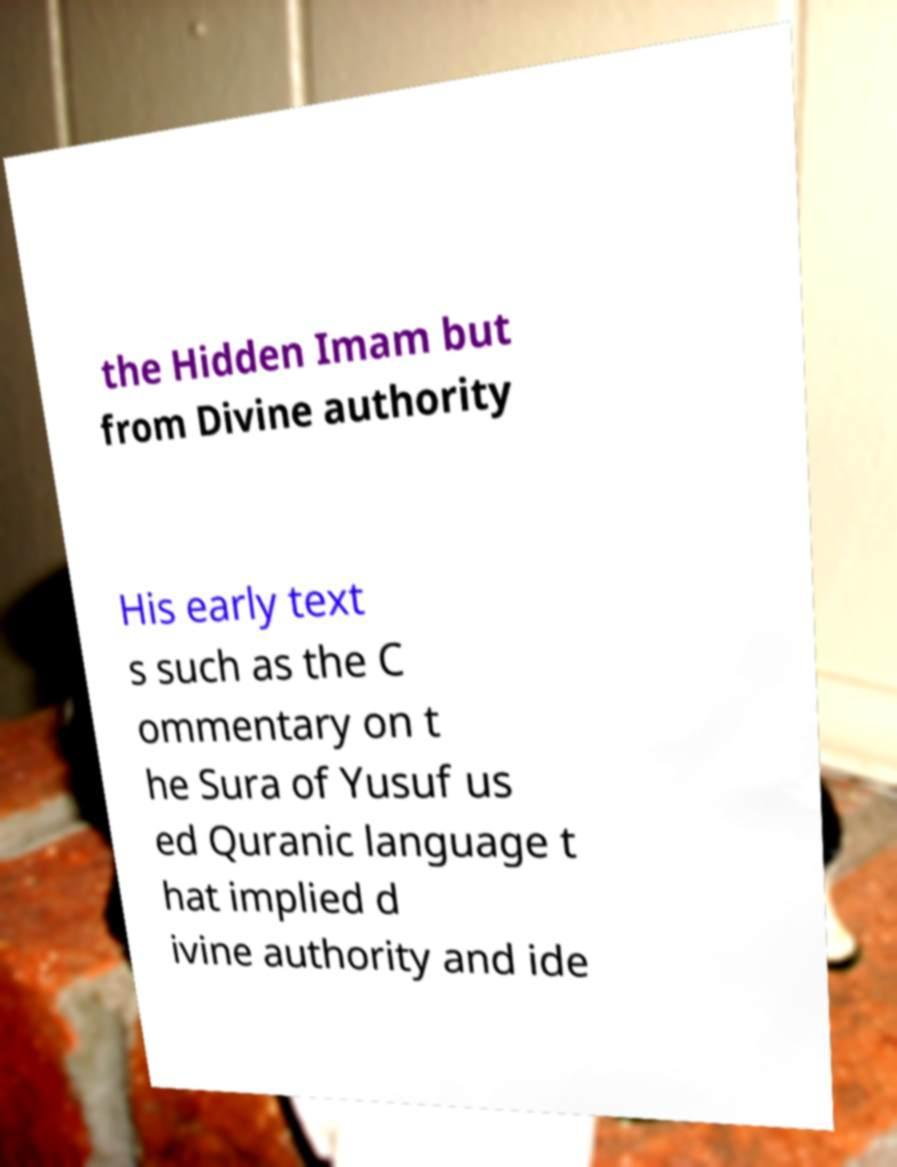Please identify and transcribe the text found in this image. the Hidden Imam but from Divine authority His early text s such as the C ommentary on t he Sura of Yusuf us ed Quranic language t hat implied d ivine authority and ide 